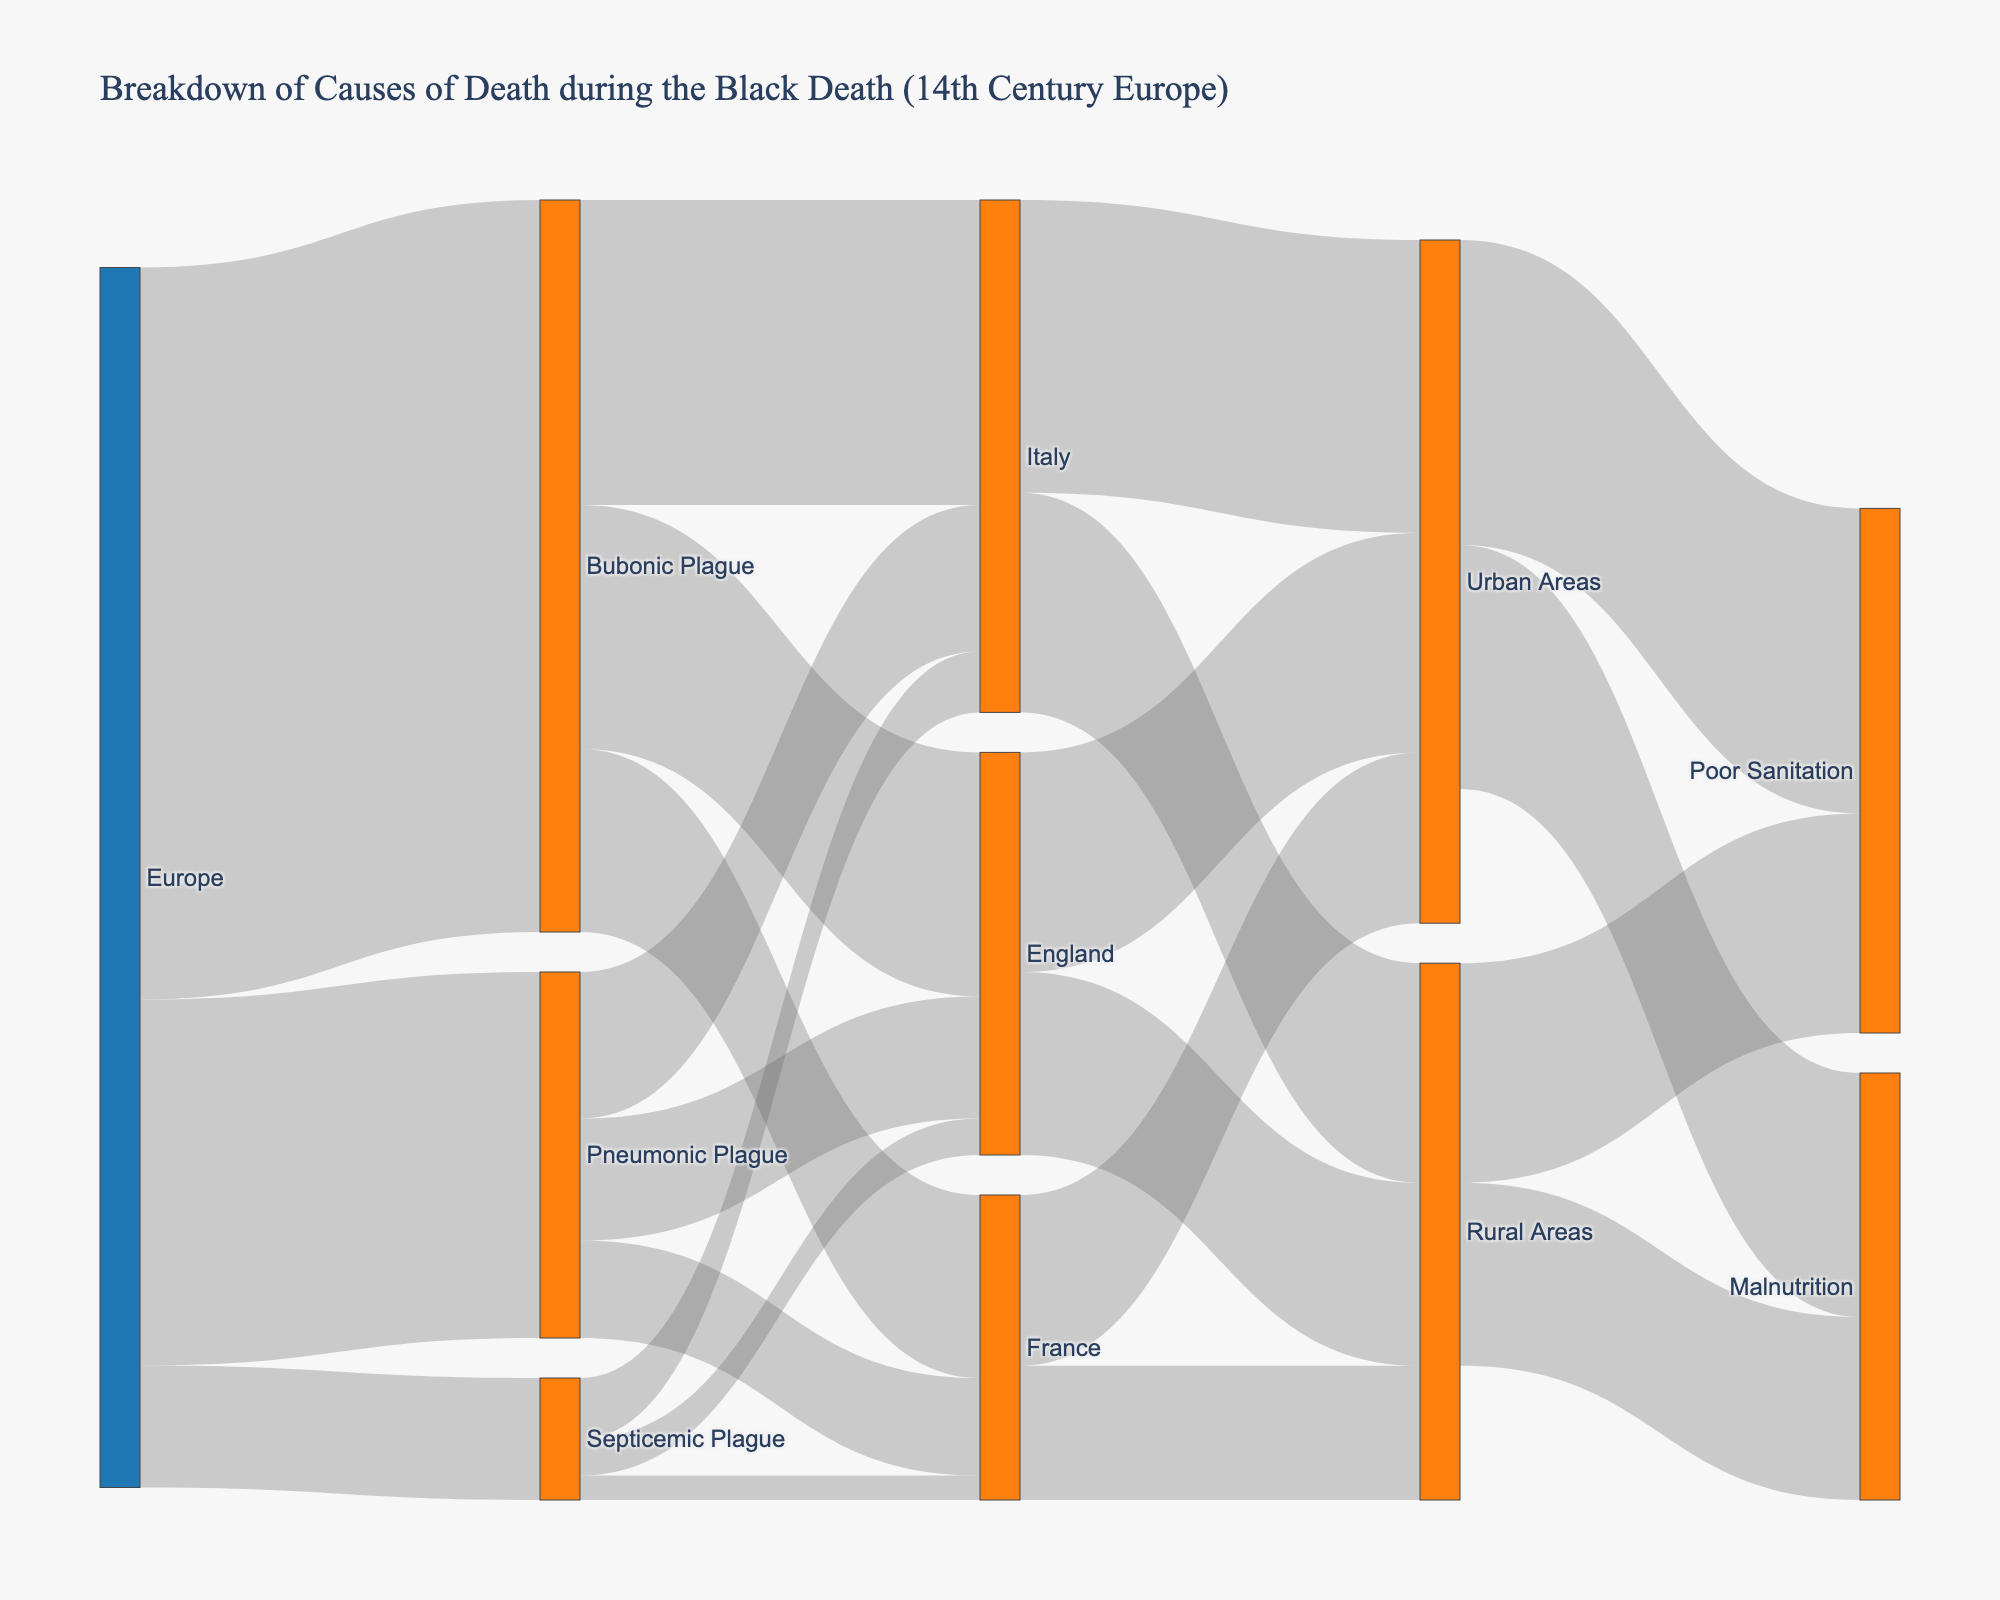What's the most common cause of death during the Black Death in all of Europe? The thickest flow from "Europe" to a cause category indicates the most common cause. The Sankey diagram shows the largest value connecting Europe to the Bubonic Plague.
Answer: Bubonic Plague How much did malnutrition contribute to death in urban areas compared to rural areas in England? Compare the values of "Malnutrition" connected to "Urban Areas" and "Rural Areas". For England, "Urban Areas" have a value of 18, and "Rural Areas" are part of the total malnutrition value of 15 for all rural areas, but to know exact English rural malnutrition, sum all rural deaths specifically.
Answer: 18 (Urban) vs. (part of) 15 (Rural) Which country had the highest deaths due to the Pneumonic Plague? Follow the flow from "Pneumonic Plague" to each country. Italy shows the largest value as 12.
Answer: Italy How many total deaths occurred in Rural Areas across all causes of death in France? Sum the values of all flows ending in "Rural Areas" in France: Bubonic Plague (11) and Pneumonic Plague (11). There is no separate summation for Septicemic Plague or malnutrition for countries; use provided numbers.
Answer: 11 What was the least common cause of death in Italy, and how many deaths was it responsible for? Identify the smallest flow leading to "Italy" from any plague type. Septicemic Plague shows 5 deaths.
Answer: Septicemic Plague, 5 Compare the deaths due to Poor Sanitation between Urban and Rural areas in France. Check values connecting "Poor Sanitation" to both "Urban Areas" and "Rural Areas" in France: "Urban Areas" = 25 (total), "Rural Areas" = 18 (total). Specific breakdown for France needs directing to totals.
Answer: Higher in Urban Areas What is the proportion of deaths in England attributed to Bubonic Plague relative to the total deaths in England? Total England deaths sum: Bubonic (20) + Pneumonic (10) + Septicemic (3) = 33. Proportion of Bubonic deaths: 20 out of 33.
Answer: 20/33 or about 60.6% Which area had the overall highest deaths due to Poor Sanitation? Compare flows into "Poor Sanitation" for Urban (25) vs. Rural (18). Urban Areas win.
Answer: Urban Areas Which category had the smallest numeric representation in the entire diagram? Identify the smallest value among all categories. Septicemic Plague in France only has 2 deaths.
Answer: Septicemic Plague (France, 2) 